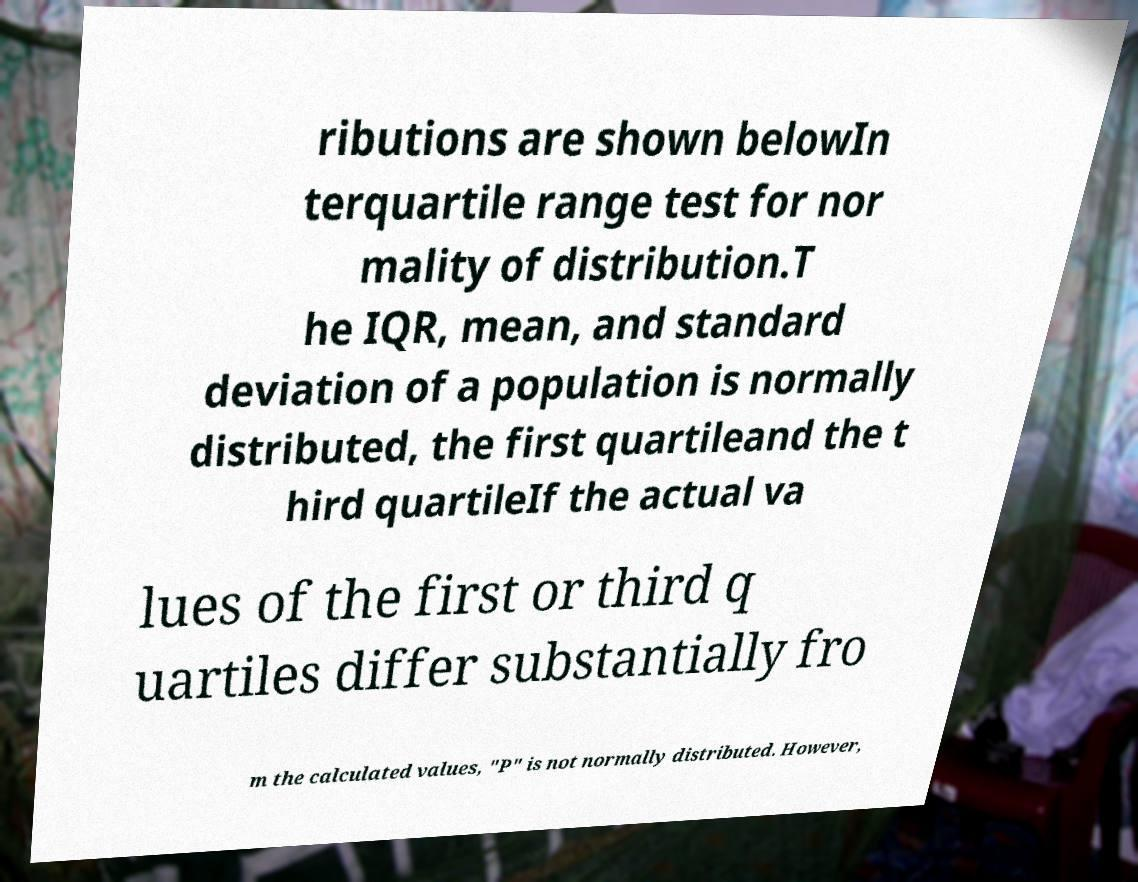Could you extract and type out the text from this image? ributions are shown belowIn terquartile range test for nor mality of distribution.T he IQR, mean, and standard deviation of a population is normally distributed, the first quartileand the t hird quartileIf the actual va lues of the first or third q uartiles differ substantially fro m the calculated values, "P" is not normally distributed. However, 